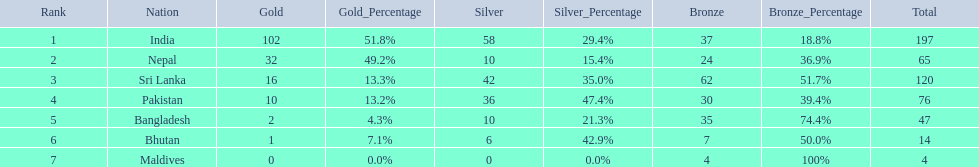What countries attended the 1999 south asian games? India, Nepal, Sri Lanka, Pakistan, Bangladesh, Bhutan, Maldives. Which of these countries had 32 gold medals? Nepal. 